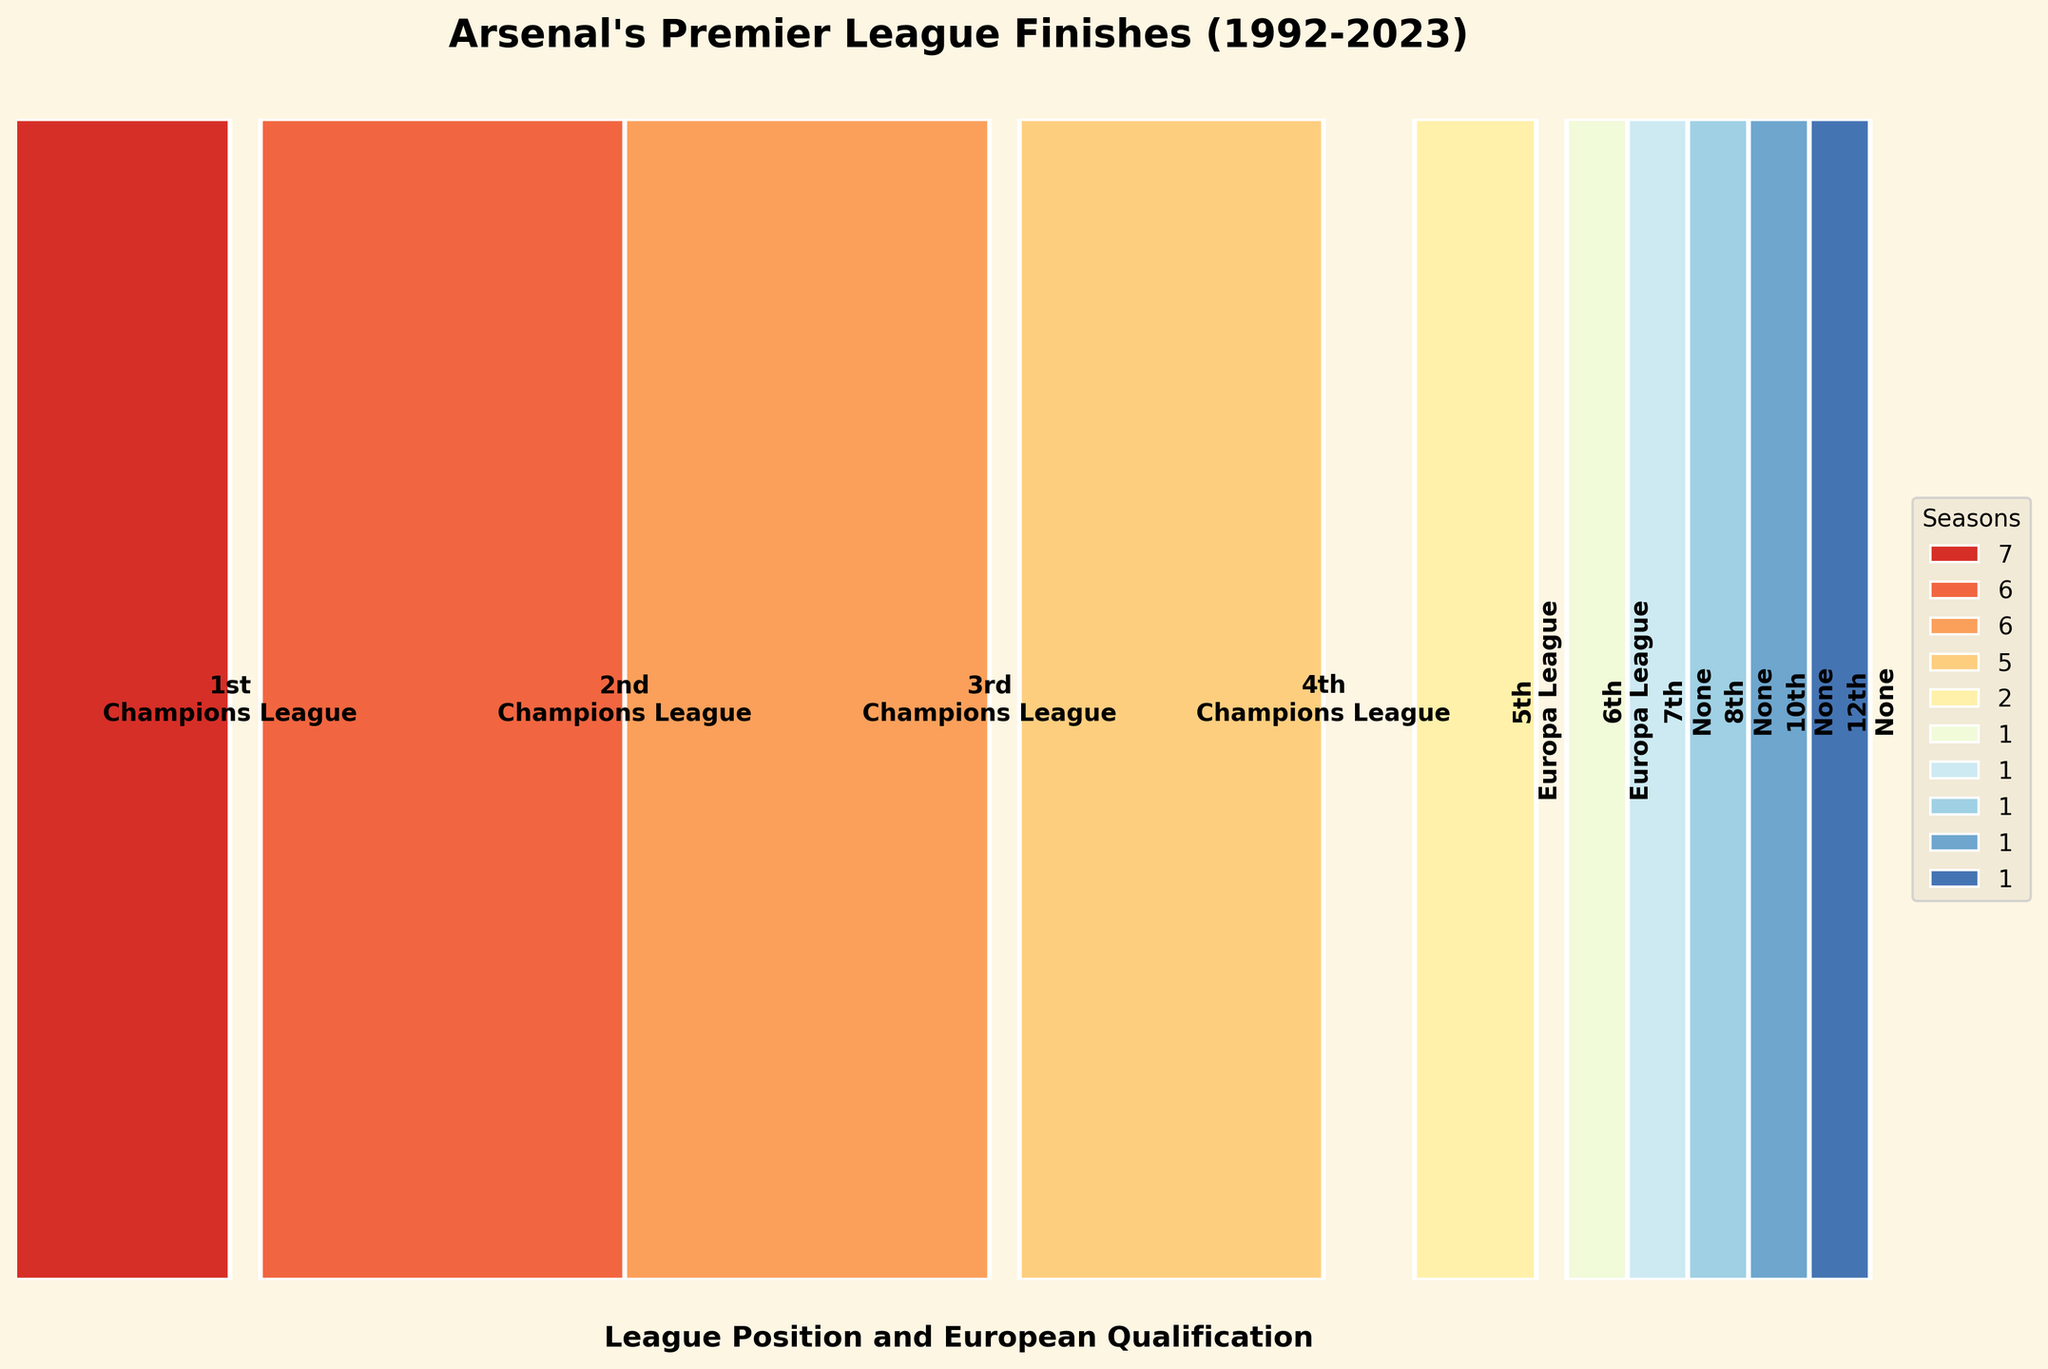Which league position has the most seasons? The figure shows that Arsenal finished 1st in the league for 7 seasons, making it the position with the most seasons.
Answer: 1st How many seasons did Arsenal finish outside of European qualification spots? The figure lists 1 season each in 7th, 8th, 10th, and 12th positions, totaling 4 seasons outside European qualification.
Answer: 4 What's the sum of seasons Arsenal finished in a Champions League spot? Adding the seasons in positions 1st to 4th, 7 + 6 + 6 + 5 = 24, so Arsenal finished in a Champions League spot for 24 seasons.
Answer: 24 Which European qualification has the least seasons? The figure shows that the Europa League qualification has only 3 seasons (2 for 5th and 1 for 6th), which is the fewest compared to others.
Answer: Europa League How many more seasons did Arsenal finish 1st compared to 4th? Arsenal finished 1st for 7 seasons and 4th for 5 seasons. The difference is 7 - 5 = 2.
Answer: 2 Which positions did Arsenal finish in only once? The figure shows that Arsenal finished in positions 7th, 8th, 10th, and 12th each only once.
Answer: 7th, 8th, 10th, 12th Is the number of seasons Arsenal finished in a non-European qualifying spot higher than those in Europa League spots? Arsenal finished in non-European spots for 4 seasons and in Europa League spots for 3 seasons. 4 > 3, so yes.
Answer: Yes What's the total number of seasons Arsenal has played in the Premier League since 1992? Summing up all the seasons listed (7 + 6 + 6 + 5 + 2 + 1 + 1 + 1 + 1 + 1) = 31, so Arsenal has played 31 seasons.
Answer: 31 